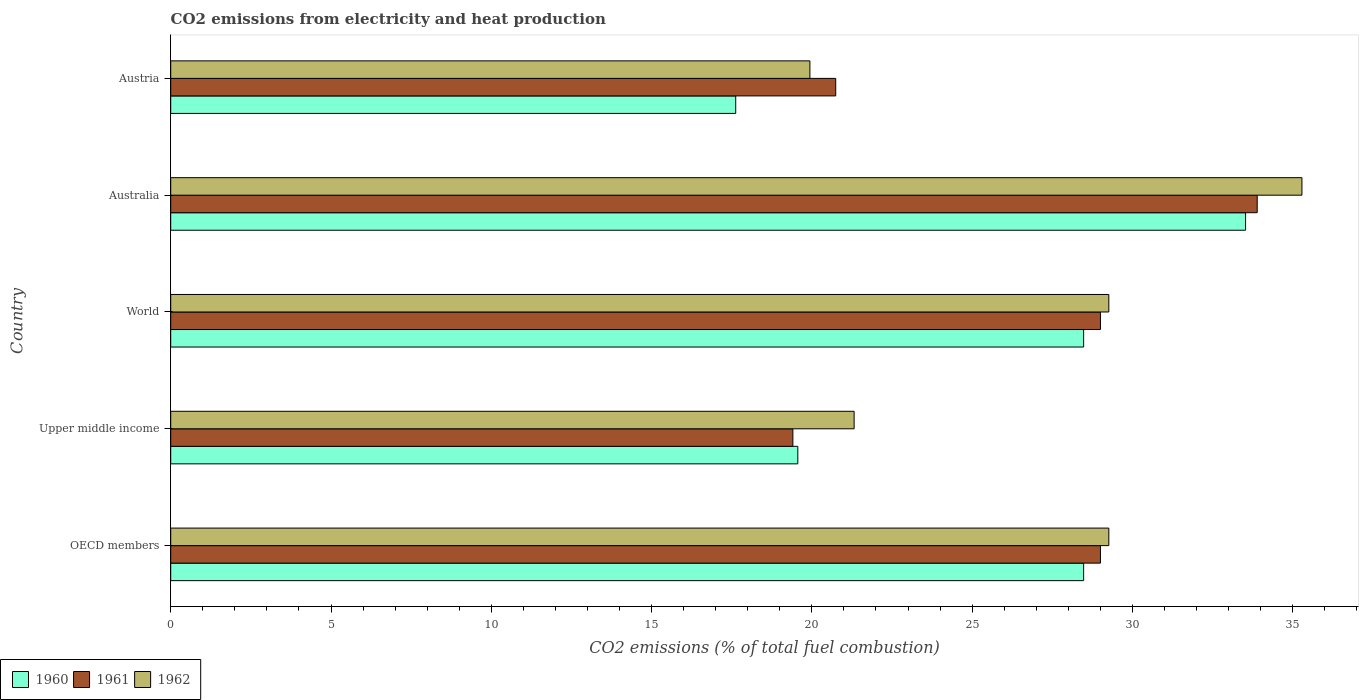How many different coloured bars are there?
Ensure brevity in your answer.  3. How many groups of bars are there?
Keep it short and to the point. 5. Are the number of bars on each tick of the Y-axis equal?
Your answer should be very brief. Yes. In how many cases, is the number of bars for a given country not equal to the number of legend labels?
Offer a terse response. 0. What is the amount of CO2 emitted in 1960 in World?
Ensure brevity in your answer.  28.48. Across all countries, what is the maximum amount of CO2 emitted in 1961?
Ensure brevity in your answer.  33.89. Across all countries, what is the minimum amount of CO2 emitted in 1962?
Your answer should be compact. 19.94. In which country was the amount of CO2 emitted in 1960 minimum?
Offer a very short reply. Austria. What is the total amount of CO2 emitted in 1960 in the graph?
Offer a very short reply. 127.68. What is the difference between the amount of CO2 emitted in 1961 in OECD members and that in Upper middle income?
Provide a succinct answer. 9.6. What is the difference between the amount of CO2 emitted in 1961 in World and the amount of CO2 emitted in 1960 in OECD members?
Provide a short and direct response. 0.52. What is the average amount of CO2 emitted in 1962 per country?
Provide a succinct answer. 27.02. What is the difference between the amount of CO2 emitted in 1962 and amount of CO2 emitted in 1961 in Upper middle income?
Your answer should be very brief. 1.91. In how many countries, is the amount of CO2 emitted in 1960 greater than 32 %?
Offer a terse response. 1. What is the ratio of the amount of CO2 emitted in 1960 in Australia to that in World?
Offer a very short reply. 1.18. Is the amount of CO2 emitted in 1962 in OECD members less than that in Upper middle income?
Offer a very short reply. No. Is the difference between the amount of CO2 emitted in 1962 in Austria and OECD members greater than the difference between the amount of CO2 emitted in 1961 in Austria and OECD members?
Your answer should be very brief. No. What is the difference between the highest and the second highest amount of CO2 emitted in 1961?
Offer a terse response. 4.89. What is the difference between the highest and the lowest amount of CO2 emitted in 1962?
Your response must be concise. 15.35. Is the sum of the amount of CO2 emitted in 1960 in Australia and Austria greater than the maximum amount of CO2 emitted in 1962 across all countries?
Your answer should be very brief. Yes. What does the 1st bar from the top in Upper middle income represents?
Provide a succinct answer. 1962. Is it the case that in every country, the sum of the amount of CO2 emitted in 1960 and amount of CO2 emitted in 1961 is greater than the amount of CO2 emitted in 1962?
Your response must be concise. Yes. How many bars are there?
Your answer should be very brief. 15. Does the graph contain grids?
Offer a very short reply. No. Where does the legend appear in the graph?
Offer a terse response. Bottom left. How are the legend labels stacked?
Offer a terse response. Horizontal. What is the title of the graph?
Your answer should be compact. CO2 emissions from electricity and heat production. Does "2008" appear as one of the legend labels in the graph?
Keep it short and to the point. No. What is the label or title of the X-axis?
Offer a very short reply. CO2 emissions (% of total fuel combustion). What is the CO2 emissions (% of total fuel combustion) of 1960 in OECD members?
Make the answer very short. 28.48. What is the CO2 emissions (% of total fuel combustion) in 1961 in OECD members?
Provide a short and direct response. 29. What is the CO2 emissions (% of total fuel combustion) of 1962 in OECD members?
Make the answer very short. 29.26. What is the CO2 emissions (% of total fuel combustion) of 1960 in Upper middle income?
Your response must be concise. 19.56. What is the CO2 emissions (% of total fuel combustion) in 1961 in Upper middle income?
Provide a succinct answer. 19.41. What is the CO2 emissions (% of total fuel combustion) of 1962 in Upper middle income?
Offer a very short reply. 21.32. What is the CO2 emissions (% of total fuel combustion) of 1960 in World?
Ensure brevity in your answer.  28.48. What is the CO2 emissions (% of total fuel combustion) of 1961 in World?
Ensure brevity in your answer.  29. What is the CO2 emissions (% of total fuel combustion) of 1962 in World?
Provide a succinct answer. 29.26. What is the CO2 emissions (% of total fuel combustion) of 1960 in Australia?
Your response must be concise. 33.53. What is the CO2 emissions (% of total fuel combustion) of 1961 in Australia?
Keep it short and to the point. 33.89. What is the CO2 emissions (% of total fuel combustion) in 1962 in Australia?
Give a very brief answer. 35.29. What is the CO2 emissions (% of total fuel combustion) of 1960 in Austria?
Offer a very short reply. 17.63. What is the CO2 emissions (% of total fuel combustion) in 1961 in Austria?
Your answer should be compact. 20.75. What is the CO2 emissions (% of total fuel combustion) in 1962 in Austria?
Your answer should be very brief. 19.94. Across all countries, what is the maximum CO2 emissions (% of total fuel combustion) in 1960?
Your answer should be compact. 33.53. Across all countries, what is the maximum CO2 emissions (% of total fuel combustion) in 1961?
Make the answer very short. 33.89. Across all countries, what is the maximum CO2 emissions (% of total fuel combustion) of 1962?
Your answer should be compact. 35.29. Across all countries, what is the minimum CO2 emissions (% of total fuel combustion) in 1960?
Keep it short and to the point. 17.63. Across all countries, what is the minimum CO2 emissions (% of total fuel combustion) of 1961?
Offer a very short reply. 19.41. Across all countries, what is the minimum CO2 emissions (% of total fuel combustion) in 1962?
Provide a succinct answer. 19.94. What is the total CO2 emissions (% of total fuel combustion) in 1960 in the graph?
Your answer should be very brief. 127.68. What is the total CO2 emissions (% of total fuel combustion) in 1961 in the graph?
Give a very brief answer. 132.06. What is the total CO2 emissions (% of total fuel combustion) of 1962 in the graph?
Provide a short and direct response. 135.08. What is the difference between the CO2 emissions (% of total fuel combustion) of 1960 in OECD members and that in Upper middle income?
Offer a terse response. 8.92. What is the difference between the CO2 emissions (% of total fuel combustion) in 1961 in OECD members and that in Upper middle income?
Make the answer very short. 9.6. What is the difference between the CO2 emissions (% of total fuel combustion) in 1962 in OECD members and that in Upper middle income?
Your answer should be very brief. 7.95. What is the difference between the CO2 emissions (% of total fuel combustion) of 1960 in OECD members and that in Australia?
Your answer should be very brief. -5.05. What is the difference between the CO2 emissions (% of total fuel combustion) in 1961 in OECD members and that in Australia?
Give a very brief answer. -4.89. What is the difference between the CO2 emissions (% of total fuel combustion) in 1962 in OECD members and that in Australia?
Provide a short and direct response. -6.02. What is the difference between the CO2 emissions (% of total fuel combustion) in 1960 in OECD members and that in Austria?
Make the answer very short. 10.85. What is the difference between the CO2 emissions (% of total fuel combustion) of 1961 in OECD members and that in Austria?
Your answer should be compact. 8.26. What is the difference between the CO2 emissions (% of total fuel combustion) of 1962 in OECD members and that in Austria?
Your answer should be very brief. 9.33. What is the difference between the CO2 emissions (% of total fuel combustion) in 1960 in Upper middle income and that in World?
Provide a short and direct response. -8.92. What is the difference between the CO2 emissions (% of total fuel combustion) of 1961 in Upper middle income and that in World?
Provide a short and direct response. -9.6. What is the difference between the CO2 emissions (% of total fuel combustion) in 1962 in Upper middle income and that in World?
Give a very brief answer. -7.95. What is the difference between the CO2 emissions (% of total fuel combustion) in 1960 in Upper middle income and that in Australia?
Ensure brevity in your answer.  -13.97. What is the difference between the CO2 emissions (% of total fuel combustion) of 1961 in Upper middle income and that in Australia?
Offer a very short reply. -14.49. What is the difference between the CO2 emissions (% of total fuel combustion) of 1962 in Upper middle income and that in Australia?
Make the answer very short. -13.97. What is the difference between the CO2 emissions (% of total fuel combustion) in 1960 in Upper middle income and that in Austria?
Your answer should be compact. 1.94. What is the difference between the CO2 emissions (% of total fuel combustion) of 1961 in Upper middle income and that in Austria?
Give a very brief answer. -1.34. What is the difference between the CO2 emissions (% of total fuel combustion) of 1962 in Upper middle income and that in Austria?
Offer a terse response. 1.38. What is the difference between the CO2 emissions (% of total fuel combustion) in 1960 in World and that in Australia?
Offer a very short reply. -5.05. What is the difference between the CO2 emissions (% of total fuel combustion) of 1961 in World and that in Australia?
Give a very brief answer. -4.89. What is the difference between the CO2 emissions (% of total fuel combustion) of 1962 in World and that in Australia?
Your answer should be compact. -6.02. What is the difference between the CO2 emissions (% of total fuel combustion) of 1960 in World and that in Austria?
Keep it short and to the point. 10.85. What is the difference between the CO2 emissions (% of total fuel combustion) in 1961 in World and that in Austria?
Your answer should be compact. 8.26. What is the difference between the CO2 emissions (% of total fuel combustion) of 1962 in World and that in Austria?
Offer a terse response. 9.33. What is the difference between the CO2 emissions (% of total fuel combustion) of 1960 in Australia and that in Austria?
Provide a short and direct response. 15.91. What is the difference between the CO2 emissions (% of total fuel combustion) of 1961 in Australia and that in Austria?
Provide a short and direct response. 13.15. What is the difference between the CO2 emissions (% of total fuel combustion) of 1962 in Australia and that in Austria?
Give a very brief answer. 15.35. What is the difference between the CO2 emissions (% of total fuel combustion) in 1960 in OECD members and the CO2 emissions (% of total fuel combustion) in 1961 in Upper middle income?
Your answer should be very brief. 9.07. What is the difference between the CO2 emissions (% of total fuel combustion) of 1960 in OECD members and the CO2 emissions (% of total fuel combustion) of 1962 in Upper middle income?
Your response must be concise. 7.16. What is the difference between the CO2 emissions (% of total fuel combustion) in 1961 in OECD members and the CO2 emissions (% of total fuel combustion) in 1962 in Upper middle income?
Make the answer very short. 7.68. What is the difference between the CO2 emissions (% of total fuel combustion) in 1960 in OECD members and the CO2 emissions (% of total fuel combustion) in 1961 in World?
Give a very brief answer. -0.52. What is the difference between the CO2 emissions (% of total fuel combustion) in 1960 in OECD members and the CO2 emissions (% of total fuel combustion) in 1962 in World?
Give a very brief answer. -0.79. What is the difference between the CO2 emissions (% of total fuel combustion) of 1961 in OECD members and the CO2 emissions (% of total fuel combustion) of 1962 in World?
Provide a short and direct response. -0.26. What is the difference between the CO2 emissions (% of total fuel combustion) in 1960 in OECD members and the CO2 emissions (% of total fuel combustion) in 1961 in Australia?
Provide a short and direct response. -5.41. What is the difference between the CO2 emissions (% of total fuel combustion) in 1960 in OECD members and the CO2 emissions (% of total fuel combustion) in 1962 in Australia?
Your response must be concise. -6.81. What is the difference between the CO2 emissions (% of total fuel combustion) in 1961 in OECD members and the CO2 emissions (% of total fuel combustion) in 1962 in Australia?
Keep it short and to the point. -6.29. What is the difference between the CO2 emissions (% of total fuel combustion) in 1960 in OECD members and the CO2 emissions (% of total fuel combustion) in 1961 in Austria?
Offer a very short reply. 7.73. What is the difference between the CO2 emissions (% of total fuel combustion) in 1960 in OECD members and the CO2 emissions (% of total fuel combustion) in 1962 in Austria?
Offer a very short reply. 8.54. What is the difference between the CO2 emissions (% of total fuel combustion) in 1961 in OECD members and the CO2 emissions (% of total fuel combustion) in 1962 in Austria?
Your answer should be compact. 9.06. What is the difference between the CO2 emissions (% of total fuel combustion) of 1960 in Upper middle income and the CO2 emissions (% of total fuel combustion) of 1961 in World?
Provide a short and direct response. -9.44. What is the difference between the CO2 emissions (% of total fuel combustion) in 1960 in Upper middle income and the CO2 emissions (% of total fuel combustion) in 1962 in World?
Give a very brief answer. -9.7. What is the difference between the CO2 emissions (% of total fuel combustion) in 1961 in Upper middle income and the CO2 emissions (% of total fuel combustion) in 1962 in World?
Make the answer very short. -9.86. What is the difference between the CO2 emissions (% of total fuel combustion) of 1960 in Upper middle income and the CO2 emissions (% of total fuel combustion) of 1961 in Australia?
Offer a very short reply. -14.33. What is the difference between the CO2 emissions (% of total fuel combustion) in 1960 in Upper middle income and the CO2 emissions (% of total fuel combustion) in 1962 in Australia?
Your answer should be compact. -15.73. What is the difference between the CO2 emissions (% of total fuel combustion) of 1961 in Upper middle income and the CO2 emissions (% of total fuel combustion) of 1962 in Australia?
Give a very brief answer. -15.88. What is the difference between the CO2 emissions (% of total fuel combustion) in 1960 in Upper middle income and the CO2 emissions (% of total fuel combustion) in 1961 in Austria?
Offer a terse response. -1.18. What is the difference between the CO2 emissions (% of total fuel combustion) in 1960 in Upper middle income and the CO2 emissions (% of total fuel combustion) in 1962 in Austria?
Your answer should be very brief. -0.38. What is the difference between the CO2 emissions (% of total fuel combustion) of 1961 in Upper middle income and the CO2 emissions (% of total fuel combustion) of 1962 in Austria?
Give a very brief answer. -0.53. What is the difference between the CO2 emissions (% of total fuel combustion) in 1960 in World and the CO2 emissions (% of total fuel combustion) in 1961 in Australia?
Offer a terse response. -5.41. What is the difference between the CO2 emissions (% of total fuel combustion) in 1960 in World and the CO2 emissions (% of total fuel combustion) in 1962 in Australia?
Make the answer very short. -6.81. What is the difference between the CO2 emissions (% of total fuel combustion) of 1961 in World and the CO2 emissions (% of total fuel combustion) of 1962 in Australia?
Your response must be concise. -6.29. What is the difference between the CO2 emissions (% of total fuel combustion) in 1960 in World and the CO2 emissions (% of total fuel combustion) in 1961 in Austria?
Make the answer very short. 7.73. What is the difference between the CO2 emissions (% of total fuel combustion) of 1960 in World and the CO2 emissions (% of total fuel combustion) of 1962 in Austria?
Provide a short and direct response. 8.54. What is the difference between the CO2 emissions (% of total fuel combustion) in 1961 in World and the CO2 emissions (% of total fuel combustion) in 1962 in Austria?
Give a very brief answer. 9.06. What is the difference between the CO2 emissions (% of total fuel combustion) of 1960 in Australia and the CO2 emissions (% of total fuel combustion) of 1961 in Austria?
Ensure brevity in your answer.  12.79. What is the difference between the CO2 emissions (% of total fuel combustion) of 1960 in Australia and the CO2 emissions (% of total fuel combustion) of 1962 in Austria?
Your answer should be very brief. 13.59. What is the difference between the CO2 emissions (% of total fuel combustion) in 1961 in Australia and the CO2 emissions (% of total fuel combustion) in 1962 in Austria?
Keep it short and to the point. 13.95. What is the average CO2 emissions (% of total fuel combustion) of 1960 per country?
Make the answer very short. 25.54. What is the average CO2 emissions (% of total fuel combustion) in 1961 per country?
Offer a terse response. 26.41. What is the average CO2 emissions (% of total fuel combustion) of 1962 per country?
Your response must be concise. 27.02. What is the difference between the CO2 emissions (% of total fuel combustion) of 1960 and CO2 emissions (% of total fuel combustion) of 1961 in OECD members?
Give a very brief answer. -0.52. What is the difference between the CO2 emissions (% of total fuel combustion) in 1960 and CO2 emissions (% of total fuel combustion) in 1962 in OECD members?
Offer a very short reply. -0.79. What is the difference between the CO2 emissions (% of total fuel combustion) of 1961 and CO2 emissions (% of total fuel combustion) of 1962 in OECD members?
Your answer should be very brief. -0.26. What is the difference between the CO2 emissions (% of total fuel combustion) in 1960 and CO2 emissions (% of total fuel combustion) in 1961 in Upper middle income?
Give a very brief answer. 0.15. What is the difference between the CO2 emissions (% of total fuel combustion) of 1960 and CO2 emissions (% of total fuel combustion) of 1962 in Upper middle income?
Your answer should be compact. -1.76. What is the difference between the CO2 emissions (% of total fuel combustion) in 1961 and CO2 emissions (% of total fuel combustion) in 1962 in Upper middle income?
Your response must be concise. -1.91. What is the difference between the CO2 emissions (% of total fuel combustion) in 1960 and CO2 emissions (% of total fuel combustion) in 1961 in World?
Offer a terse response. -0.52. What is the difference between the CO2 emissions (% of total fuel combustion) in 1960 and CO2 emissions (% of total fuel combustion) in 1962 in World?
Provide a short and direct response. -0.79. What is the difference between the CO2 emissions (% of total fuel combustion) of 1961 and CO2 emissions (% of total fuel combustion) of 1962 in World?
Keep it short and to the point. -0.26. What is the difference between the CO2 emissions (% of total fuel combustion) of 1960 and CO2 emissions (% of total fuel combustion) of 1961 in Australia?
Keep it short and to the point. -0.36. What is the difference between the CO2 emissions (% of total fuel combustion) in 1960 and CO2 emissions (% of total fuel combustion) in 1962 in Australia?
Your response must be concise. -1.76. What is the difference between the CO2 emissions (% of total fuel combustion) of 1961 and CO2 emissions (% of total fuel combustion) of 1962 in Australia?
Provide a short and direct response. -1.4. What is the difference between the CO2 emissions (% of total fuel combustion) in 1960 and CO2 emissions (% of total fuel combustion) in 1961 in Austria?
Provide a succinct answer. -3.12. What is the difference between the CO2 emissions (% of total fuel combustion) in 1960 and CO2 emissions (% of total fuel combustion) in 1962 in Austria?
Make the answer very short. -2.31. What is the difference between the CO2 emissions (% of total fuel combustion) in 1961 and CO2 emissions (% of total fuel combustion) in 1962 in Austria?
Keep it short and to the point. 0.81. What is the ratio of the CO2 emissions (% of total fuel combustion) in 1960 in OECD members to that in Upper middle income?
Your response must be concise. 1.46. What is the ratio of the CO2 emissions (% of total fuel combustion) of 1961 in OECD members to that in Upper middle income?
Make the answer very short. 1.49. What is the ratio of the CO2 emissions (% of total fuel combustion) of 1962 in OECD members to that in Upper middle income?
Offer a very short reply. 1.37. What is the ratio of the CO2 emissions (% of total fuel combustion) of 1960 in OECD members to that in World?
Your answer should be compact. 1. What is the ratio of the CO2 emissions (% of total fuel combustion) of 1961 in OECD members to that in World?
Provide a succinct answer. 1. What is the ratio of the CO2 emissions (% of total fuel combustion) of 1960 in OECD members to that in Australia?
Offer a very short reply. 0.85. What is the ratio of the CO2 emissions (% of total fuel combustion) of 1961 in OECD members to that in Australia?
Ensure brevity in your answer.  0.86. What is the ratio of the CO2 emissions (% of total fuel combustion) in 1962 in OECD members to that in Australia?
Offer a very short reply. 0.83. What is the ratio of the CO2 emissions (% of total fuel combustion) in 1960 in OECD members to that in Austria?
Make the answer very short. 1.62. What is the ratio of the CO2 emissions (% of total fuel combustion) of 1961 in OECD members to that in Austria?
Make the answer very short. 1.4. What is the ratio of the CO2 emissions (% of total fuel combustion) in 1962 in OECD members to that in Austria?
Your answer should be compact. 1.47. What is the ratio of the CO2 emissions (% of total fuel combustion) of 1960 in Upper middle income to that in World?
Offer a terse response. 0.69. What is the ratio of the CO2 emissions (% of total fuel combustion) of 1961 in Upper middle income to that in World?
Offer a very short reply. 0.67. What is the ratio of the CO2 emissions (% of total fuel combustion) of 1962 in Upper middle income to that in World?
Make the answer very short. 0.73. What is the ratio of the CO2 emissions (% of total fuel combustion) in 1960 in Upper middle income to that in Australia?
Give a very brief answer. 0.58. What is the ratio of the CO2 emissions (% of total fuel combustion) in 1961 in Upper middle income to that in Australia?
Your answer should be very brief. 0.57. What is the ratio of the CO2 emissions (% of total fuel combustion) of 1962 in Upper middle income to that in Australia?
Your answer should be very brief. 0.6. What is the ratio of the CO2 emissions (% of total fuel combustion) of 1960 in Upper middle income to that in Austria?
Ensure brevity in your answer.  1.11. What is the ratio of the CO2 emissions (% of total fuel combustion) of 1961 in Upper middle income to that in Austria?
Offer a very short reply. 0.94. What is the ratio of the CO2 emissions (% of total fuel combustion) in 1962 in Upper middle income to that in Austria?
Provide a short and direct response. 1.07. What is the ratio of the CO2 emissions (% of total fuel combustion) of 1960 in World to that in Australia?
Offer a very short reply. 0.85. What is the ratio of the CO2 emissions (% of total fuel combustion) in 1961 in World to that in Australia?
Provide a succinct answer. 0.86. What is the ratio of the CO2 emissions (% of total fuel combustion) in 1962 in World to that in Australia?
Offer a terse response. 0.83. What is the ratio of the CO2 emissions (% of total fuel combustion) of 1960 in World to that in Austria?
Provide a short and direct response. 1.62. What is the ratio of the CO2 emissions (% of total fuel combustion) in 1961 in World to that in Austria?
Give a very brief answer. 1.4. What is the ratio of the CO2 emissions (% of total fuel combustion) of 1962 in World to that in Austria?
Provide a succinct answer. 1.47. What is the ratio of the CO2 emissions (% of total fuel combustion) in 1960 in Australia to that in Austria?
Your answer should be compact. 1.9. What is the ratio of the CO2 emissions (% of total fuel combustion) of 1961 in Australia to that in Austria?
Make the answer very short. 1.63. What is the ratio of the CO2 emissions (% of total fuel combustion) in 1962 in Australia to that in Austria?
Your answer should be compact. 1.77. What is the difference between the highest and the second highest CO2 emissions (% of total fuel combustion) in 1960?
Offer a very short reply. 5.05. What is the difference between the highest and the second highest CO2 emissions (% of total fuel combustion) in 1961?
Offer a terse response. 4.89. What is the difference between the highest and the second highest CO2 emissions (% of total fuel combustion) in 1962?
Your response must be concise. 6.02. What is the difference between the highest and the lowest CO2 emissions (% of total fuel combustion) in 1960?
Offer a terse response. 15.91. What is the difference between the highest and the lowest CO2 emissions (% of total fuel combustion) in 1961?
Provide a short and direct response. 14.49. What is the difference between the highest and the lowest CO2 emissions (% of total fuel combustion) in 1962?
Offer a terse response. 15.35. 